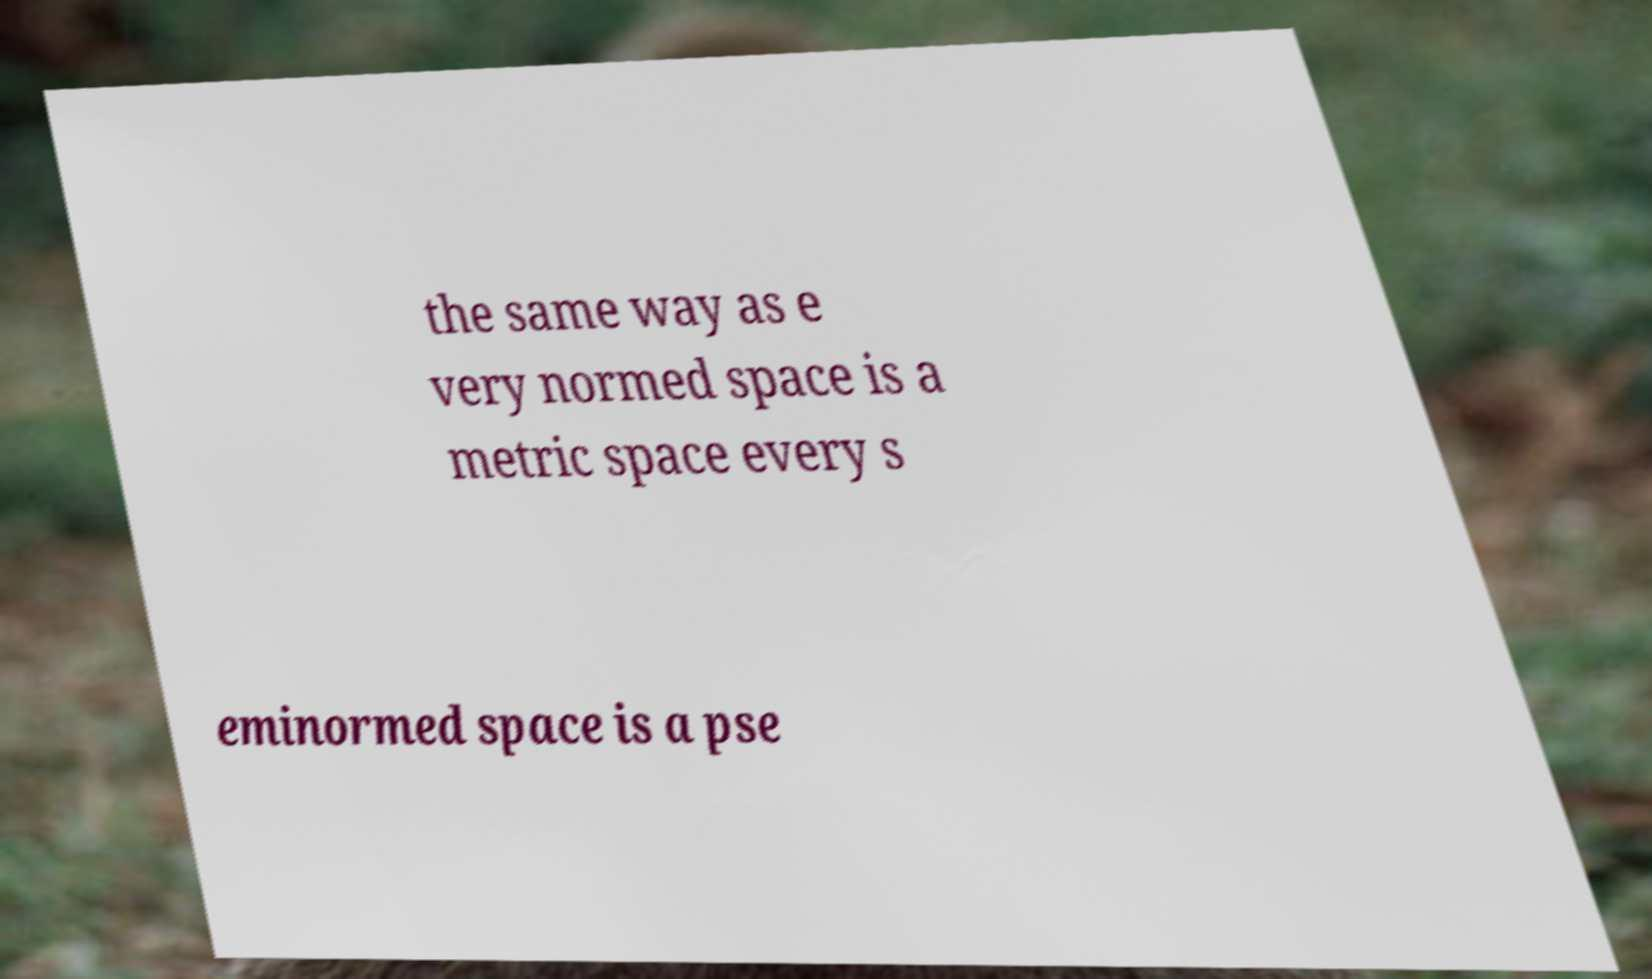For documentation purposes, I need the text within this image transcribed. Could you provide that? the same way as e very normed space is a metric space every s eminormed space is a pse 